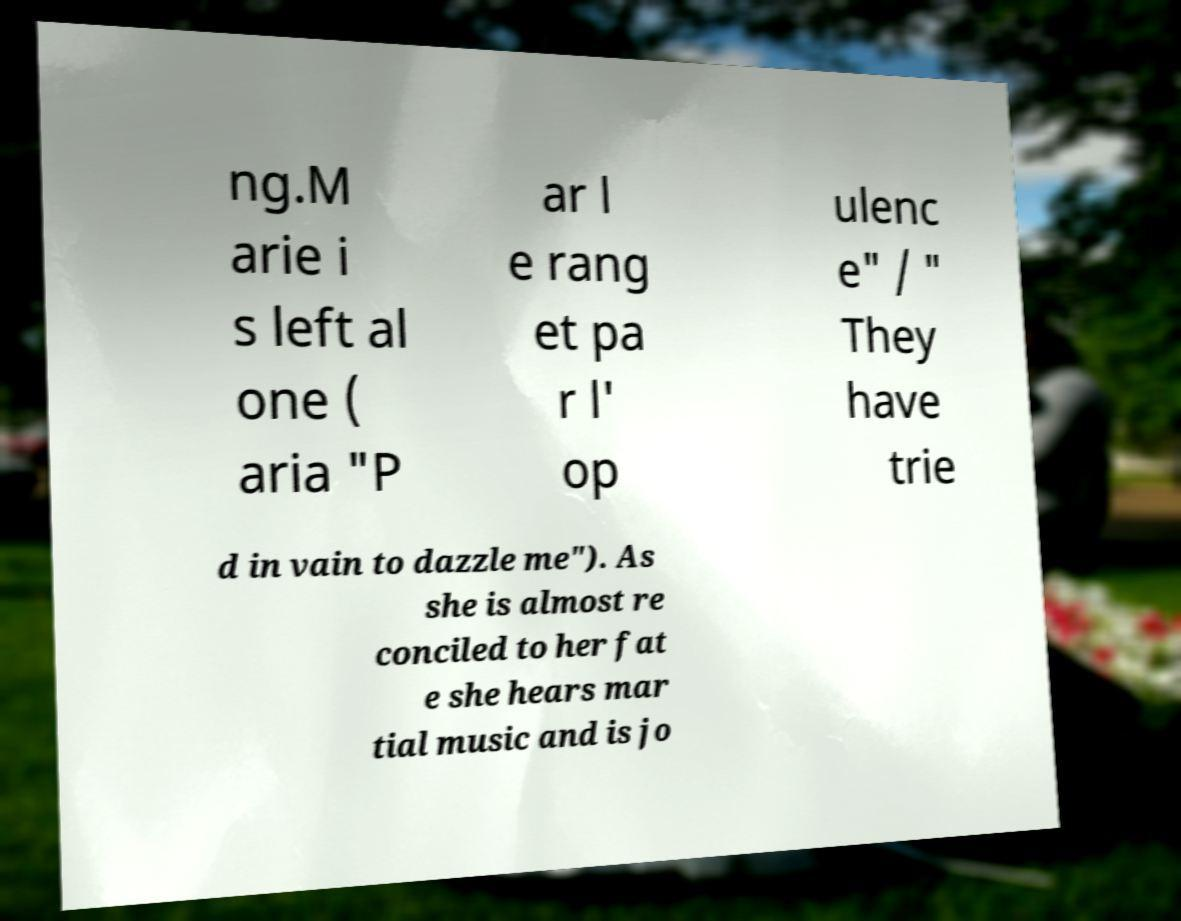I need the written content from this picture converted into text. Can you do that? ng.M arie i s left al one ( aria "P ar l e rang et pa r l' op ulenc e" / " They have trie d in vain to dazzle me"). As she is almost re conciled to her fat e she hears mar tial music and is jo 